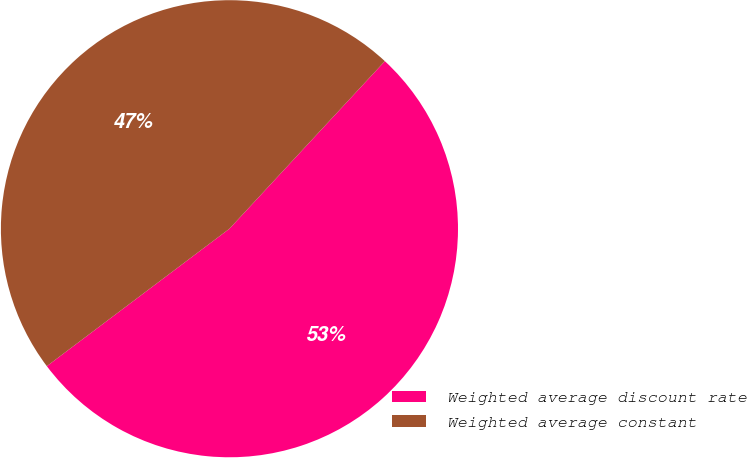Convert chart. <chart><loc_0><loc_0><loc_500><loc_500><pie_chart><fcel>Weighted average discount rate<fcel>Weighted average constant<nl><fcel>52.83%<fcel>47.17%<nl></chart> 